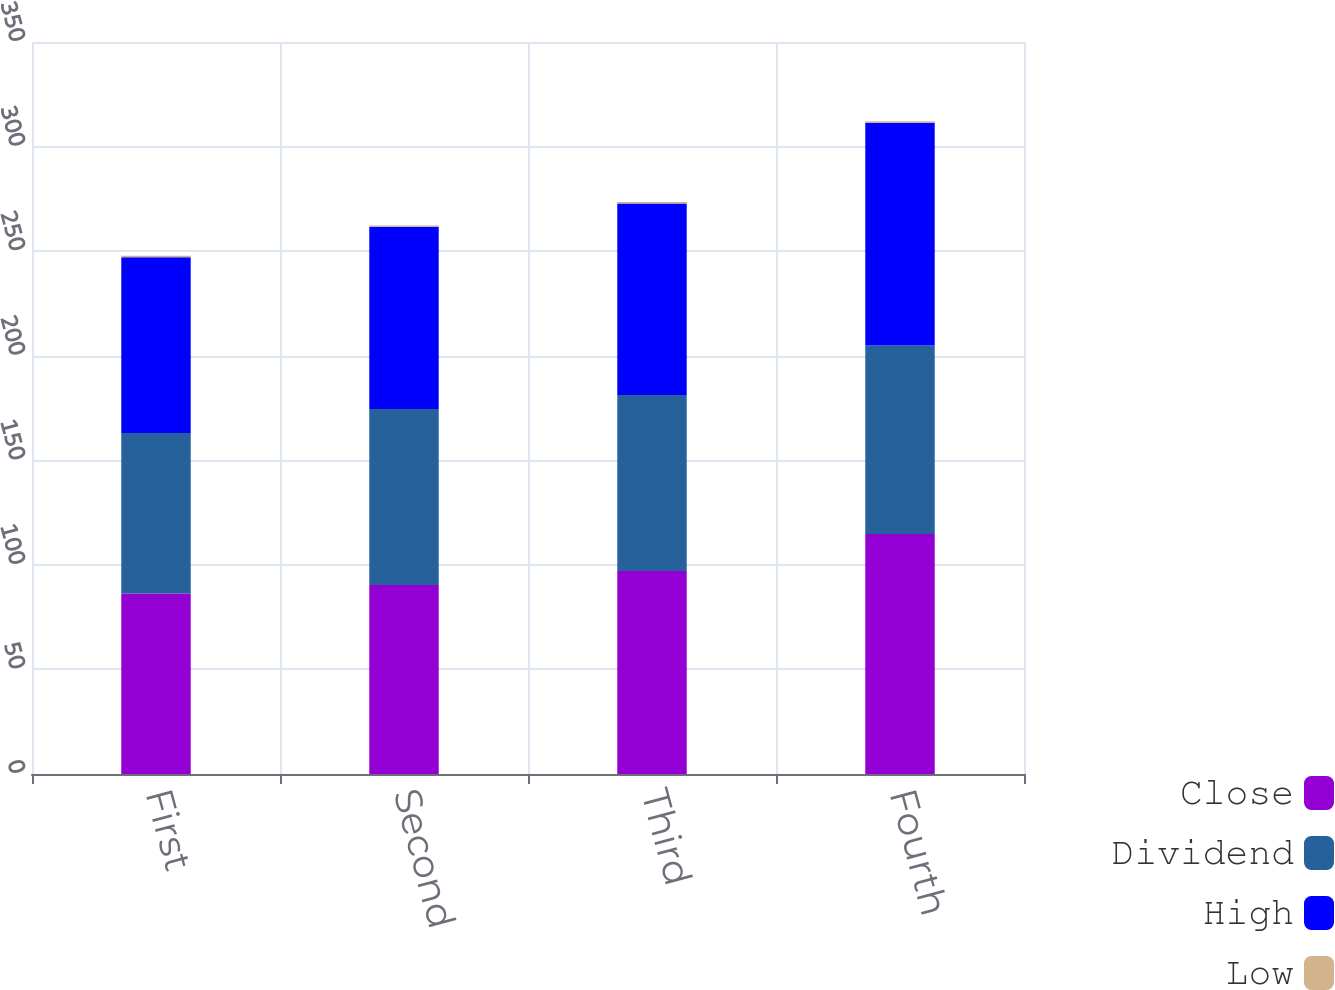Convert chart to OTSL. <chart><loc_0><loc_0><loc_500><loc_500><stacked_bar_chart><ecel><fcel>First<fcel>Second<fcel>Third<fcel>Fourth<nl><fcel>Close<fcel>86.31<fcel>90.34<fcel>97.12<fcel>114.75<nl><fcel>Dividend<fcel>76.78<fcel>84.15<fcel>84.04<fcel>90.12<nl><fcel>High<fcel>84.02<fcel>87.12<fcel>91.57<fcel>106.57<nl><fcel>Low<fcel>0.64<fcel>0.71<fcel>0.71<fcel>0.71<nl></chart> 